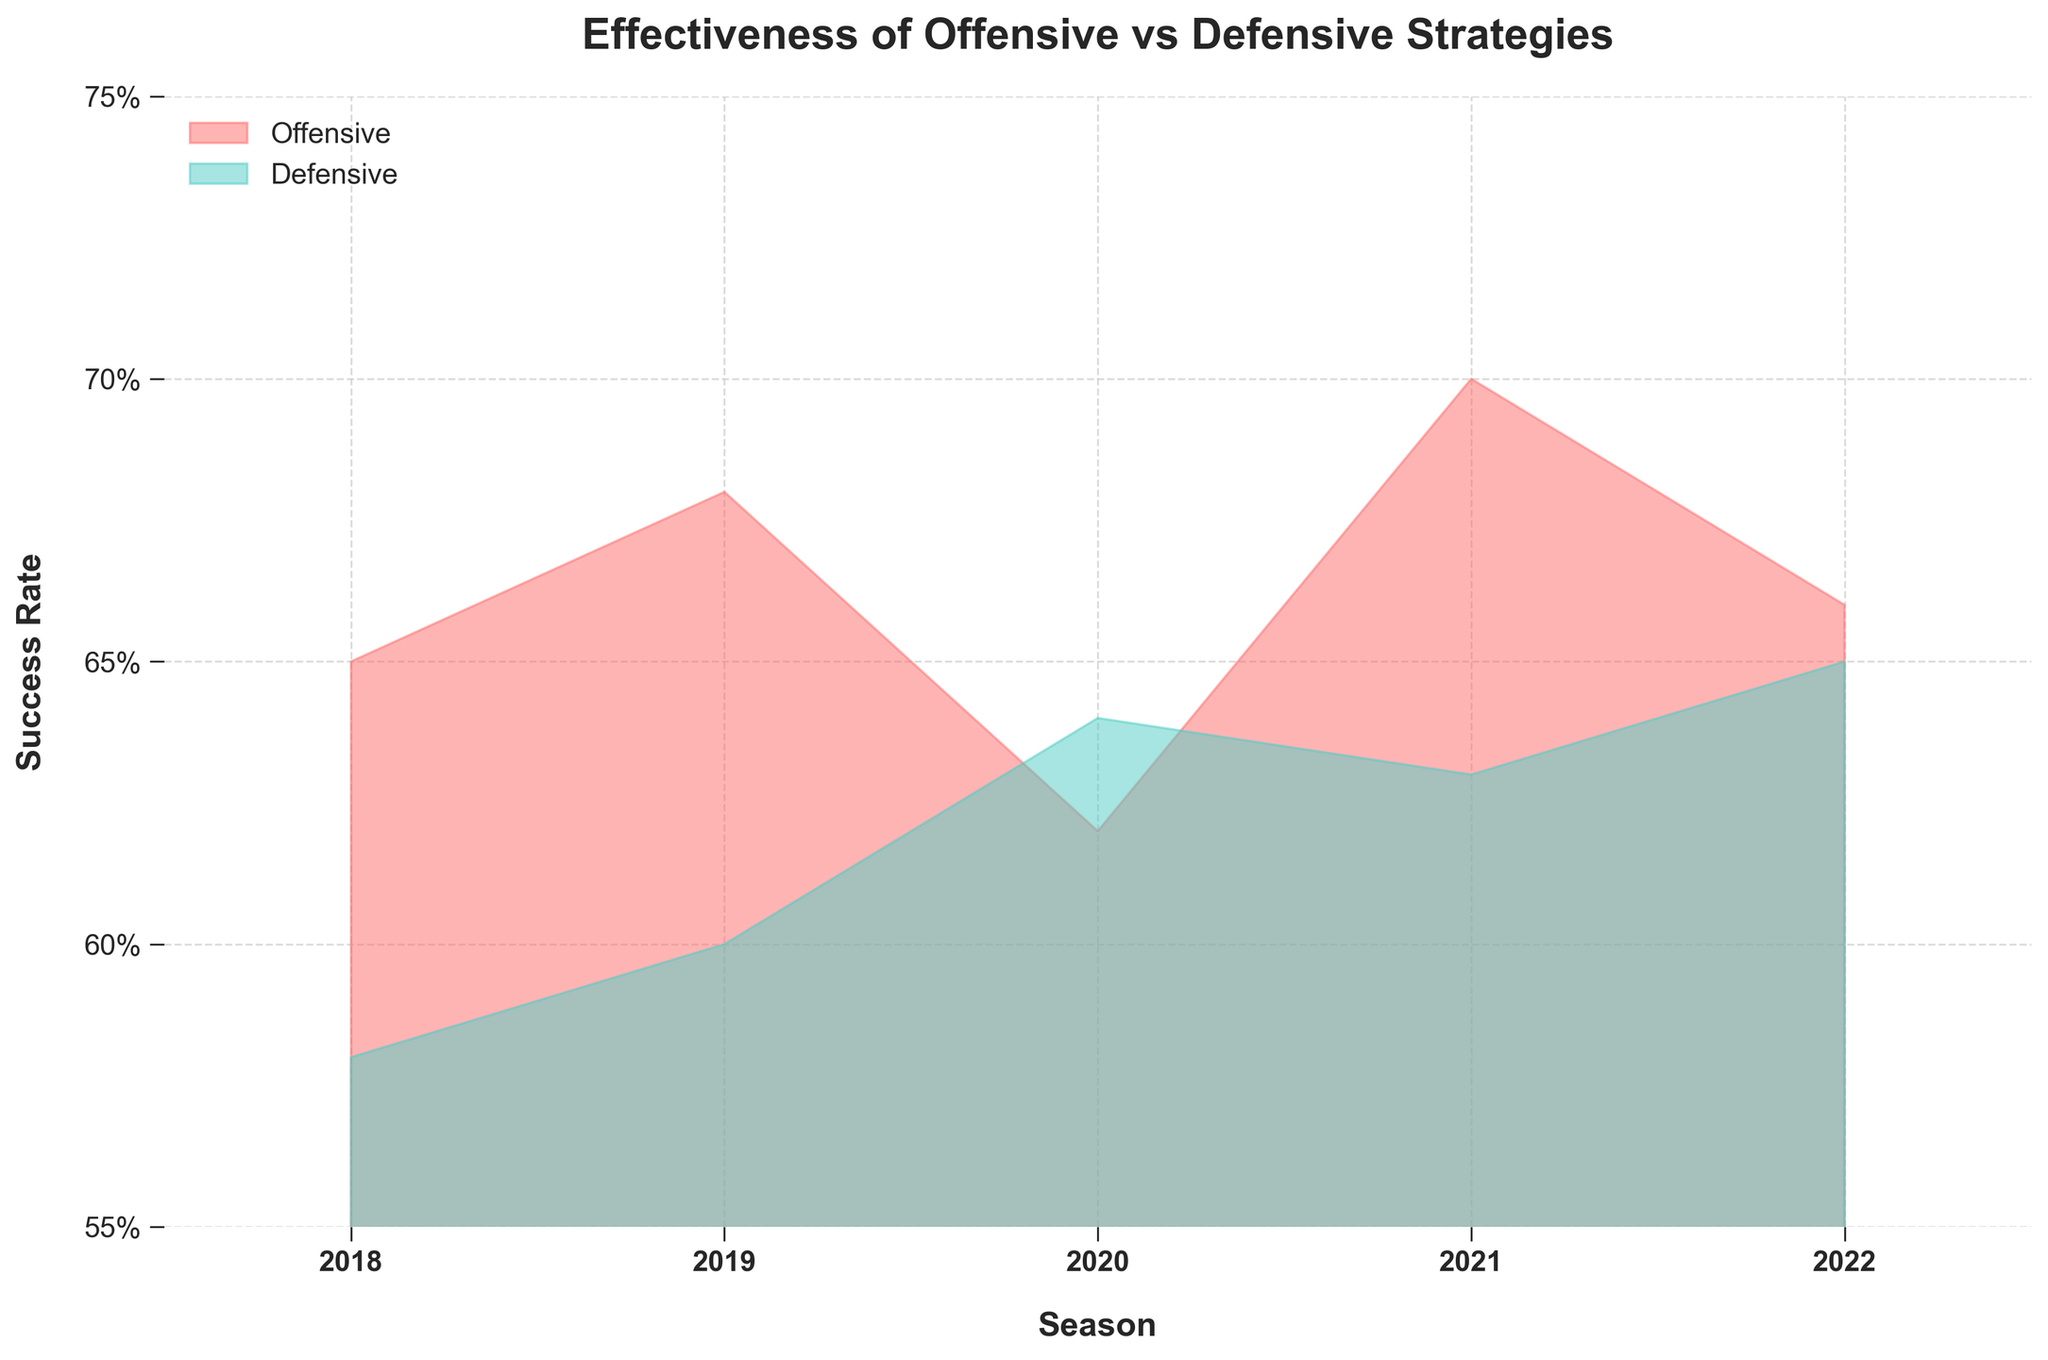What's the title of the chart? The title is displayed prominently at the top of the chart in bold text. It gives an indication of what the chart represents.
Answer: Effectiveness of Offensive vs Defensive Strategies What are the strategy types compared in this chart? The legend at the top left of the chart indicates the different strategy types by color. The red shaded area represents "Offensive" and the green shaded area represents "Defensive".
Answer: Offensive and Defensive Which season shows the highest success rate for the Offensive strategy? By observing the red area, the peak of the red shaded region indicates the greatest success rate for Offensive.
Answer: 2021 How does the Defensive strategy's success rate in 2018 compare to its success rate in 2022? Identify the points on the green shaded area corresponding to 2018 and 2022, then compare their heights.
Answer: 2018 is lower than 2022 What is the range of success rates for both strategies over the seasons? The shaded areas do not go beyond certain y-axis values. These boundary values give us the range of success rates.
Answer: 55% to 75% In which season do both strategies have the closest success rates, and what are those rates? Look for the regions where the red and green shaded areas are closest to each other.
Answer: 2020; Offensive: 62%, Defensive: 64% Calculate the average success rate for the Offensive strategy from 2018 to 2022. Add the Offensive success rates for all the seasons and then divide by the number of seasons (5). \[(65 + 68 + 62 + 70 + 66) / 5 = 66.2%\]
Answer: 66.2% Which strategy displays a more consistent success rate over the given seasons? Examine the variations in the heights of the shaded areas for both strategies. The one with less variation is more consistent.
Answer: Defensive Identify the season with the lowest success rate for the Offensive strategy and state the rate. Find the lowest point on the red shaded area and identify the corresponding season and value.
Answer: 2020; 62% Explain the trend in the Offensive strategy's success rate from 2018 to 2022. Review the changes in the height of the red shaded area from 2018 to 2022. Notice the year-to-year changes and summarize the overall trend.
Answer: It initially increases, drops in 2020, then rises again 